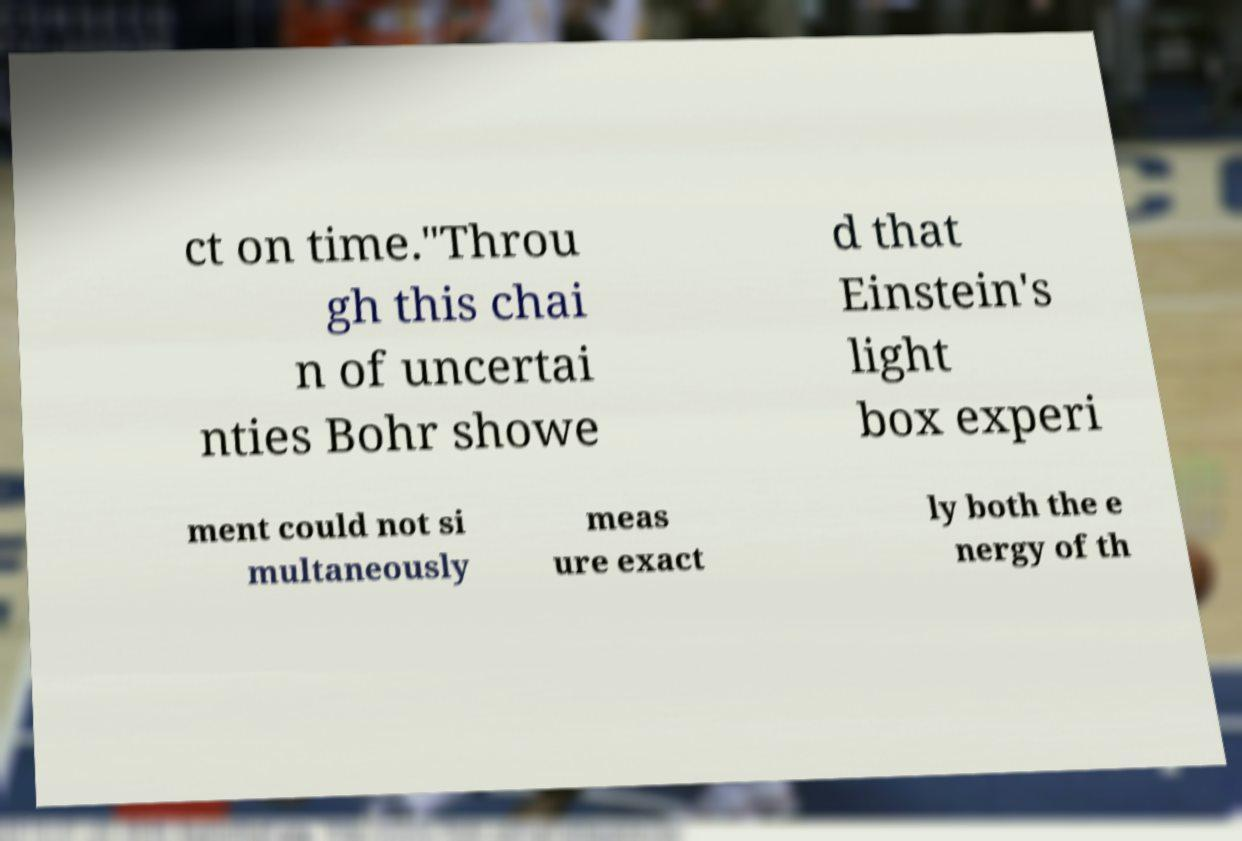Can you read and provide the text displayed in the image?This photo seems to have some interesting text. Can you extract and type it out for me? ct on time."Throu gh this chai n of uncertai nties Bohr showe d that Einstein's light box experi ment could not si multaneously meas ure exact ly both the e nergy of th 